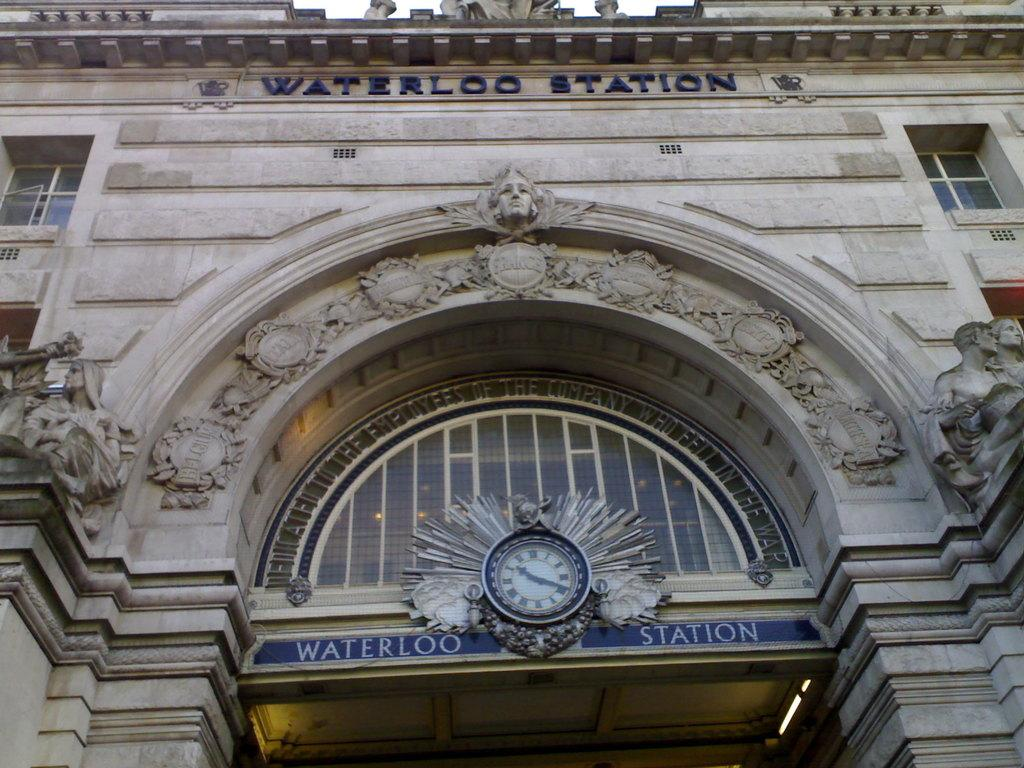<image>
Create a compact narrative representing the image presented. The Waterloo Station has an ornate clock in the archway. 